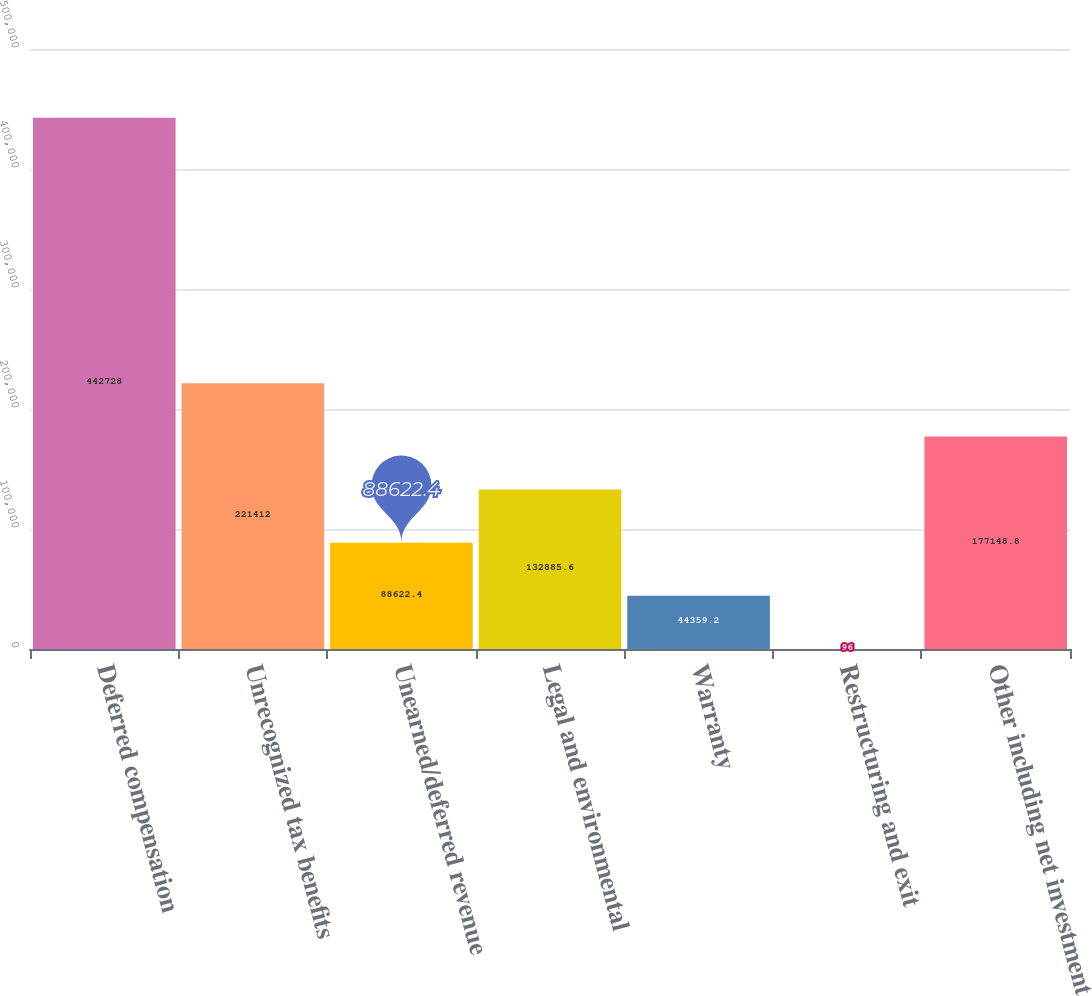Convert chart to OTSL. <chart><loc_0><loc_0><loc_500><loc_500><bar_chart><fcel>Deferred compensation<fcel>Unrecognized tax benefits<fcel>Unearned/deferred revenue<fcel>Legal and environmental<fcel>Warranty<fcel>Restructuring and exit<fcel>Other including net investment<nl><fcel>442728<fcel>221412<fcel>88622.4<fcel>132886<fcel>44359.2<fcel>96<fcel>177149<nl></chart> 